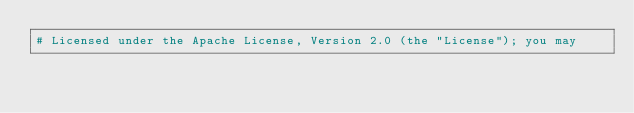<code> <loc_0><loc_0><loc_500><loc_500><_Python_># Licensed under the Apache License, Version 2.0 (the "License"); you may</code> 